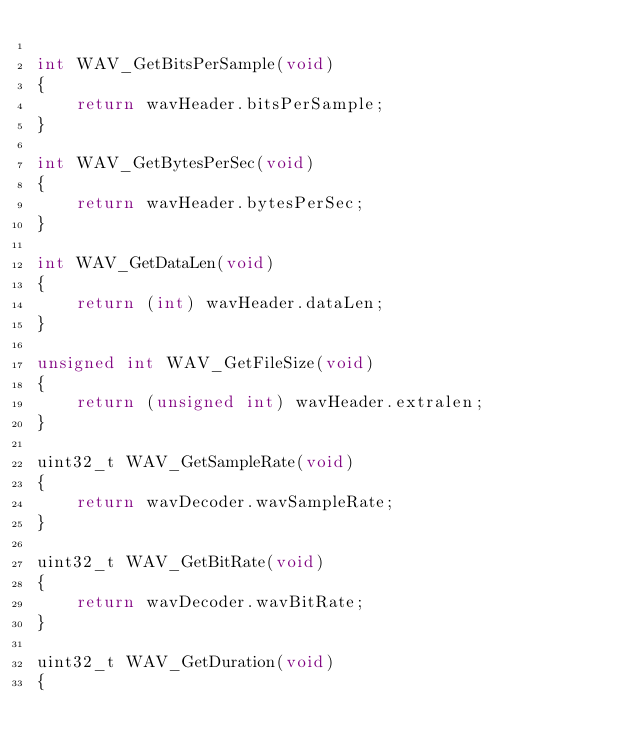Convert code to text. <code><loc_0><loc_0><loc_500><loc_500><_C_>
int WAV_GetBitsPerSample(void)
{
    return wavHeader.bitsPerSample;
}

int WAV_GetBytesPerSec(void)
{
    return wavHeader.bytesPerSec;
}

int WAV_GetDataLen(void)
{
    return (int) wavHeader.dataLen;
}

unsigned int WAV_GetFileSize(void)
{
    return (unsigned int) wavHeader.extralen;
}

uint32_t WAV_GetSampleRate(void)
{
    return wavDecoder.wavSampleRate;
}

uint32_t WAV_GetBitRate(void)
{
    return wavDecoder.wavBitRate;
}

uint32_t WAV_GetDuration(void)
{</code> 